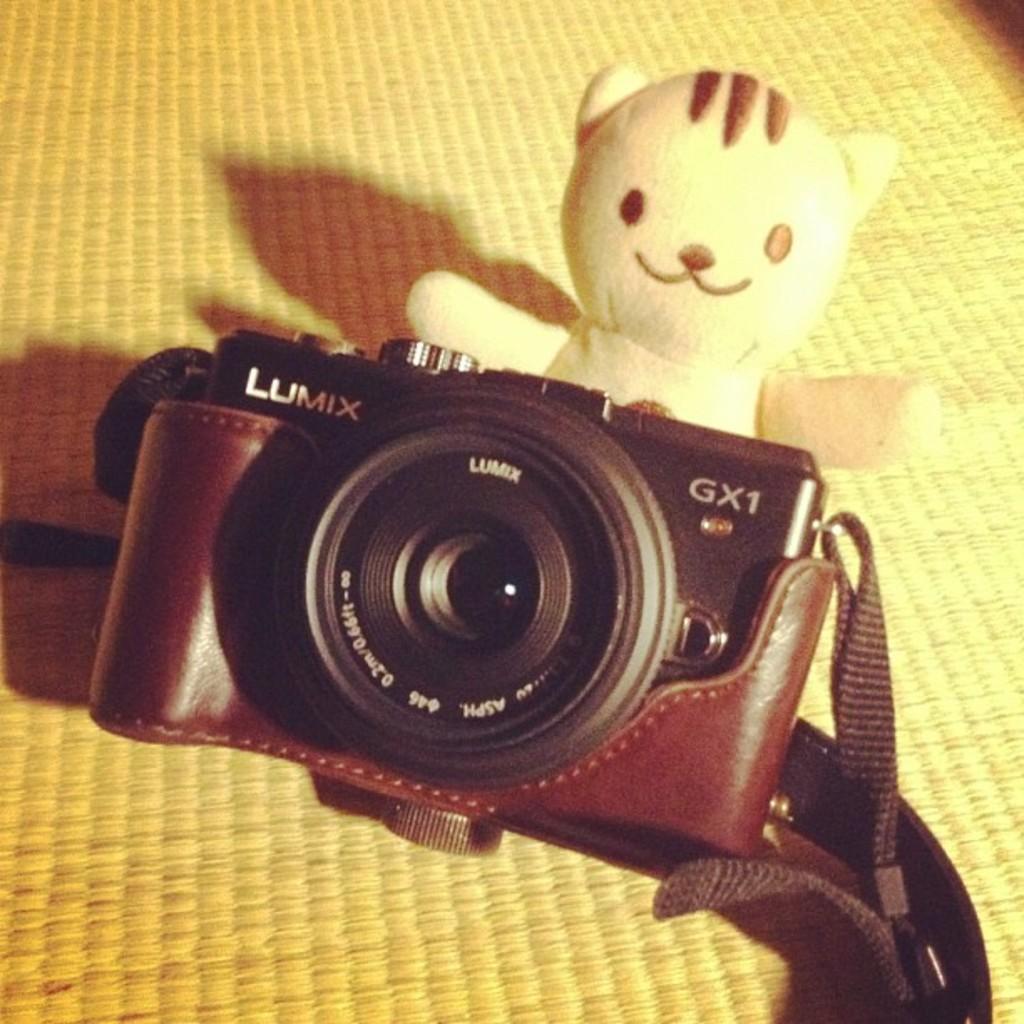Can you describe this image briefly? In this image there is a camera and there is a doll in the center. 